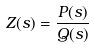Convert formula to latex. <formula><loc_0><loc_0><loc_500><loc_500>Z ( s ) = \frac { P ( s ) } { Q ( s ) }</formula> 